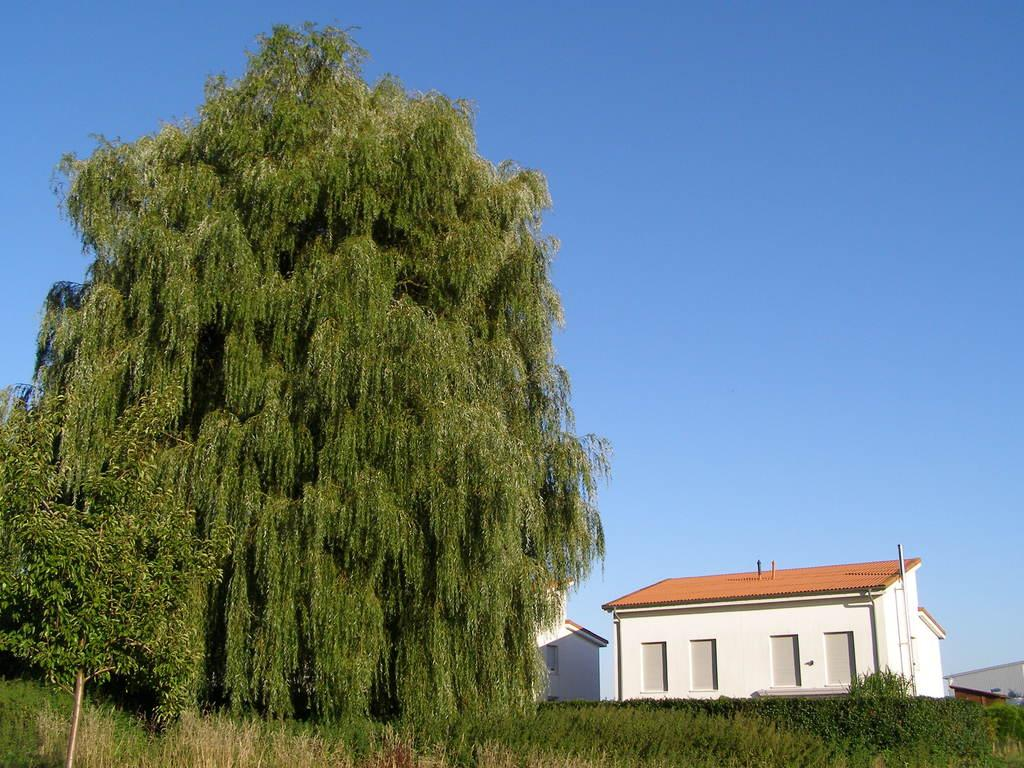What type of vegetation can be seen in the image? There are trees in the image. What color are the trees? The trees are green. What structures are visible in the background of the image? There are buildings in the background of the image. What color are the buildings? The buildings are white. What is the color of the sky in the image? The sky is blue. Where is the school located in the image? There is no school present in the image. How many people are in the crowd in the image? There is no crowd present in the image. 